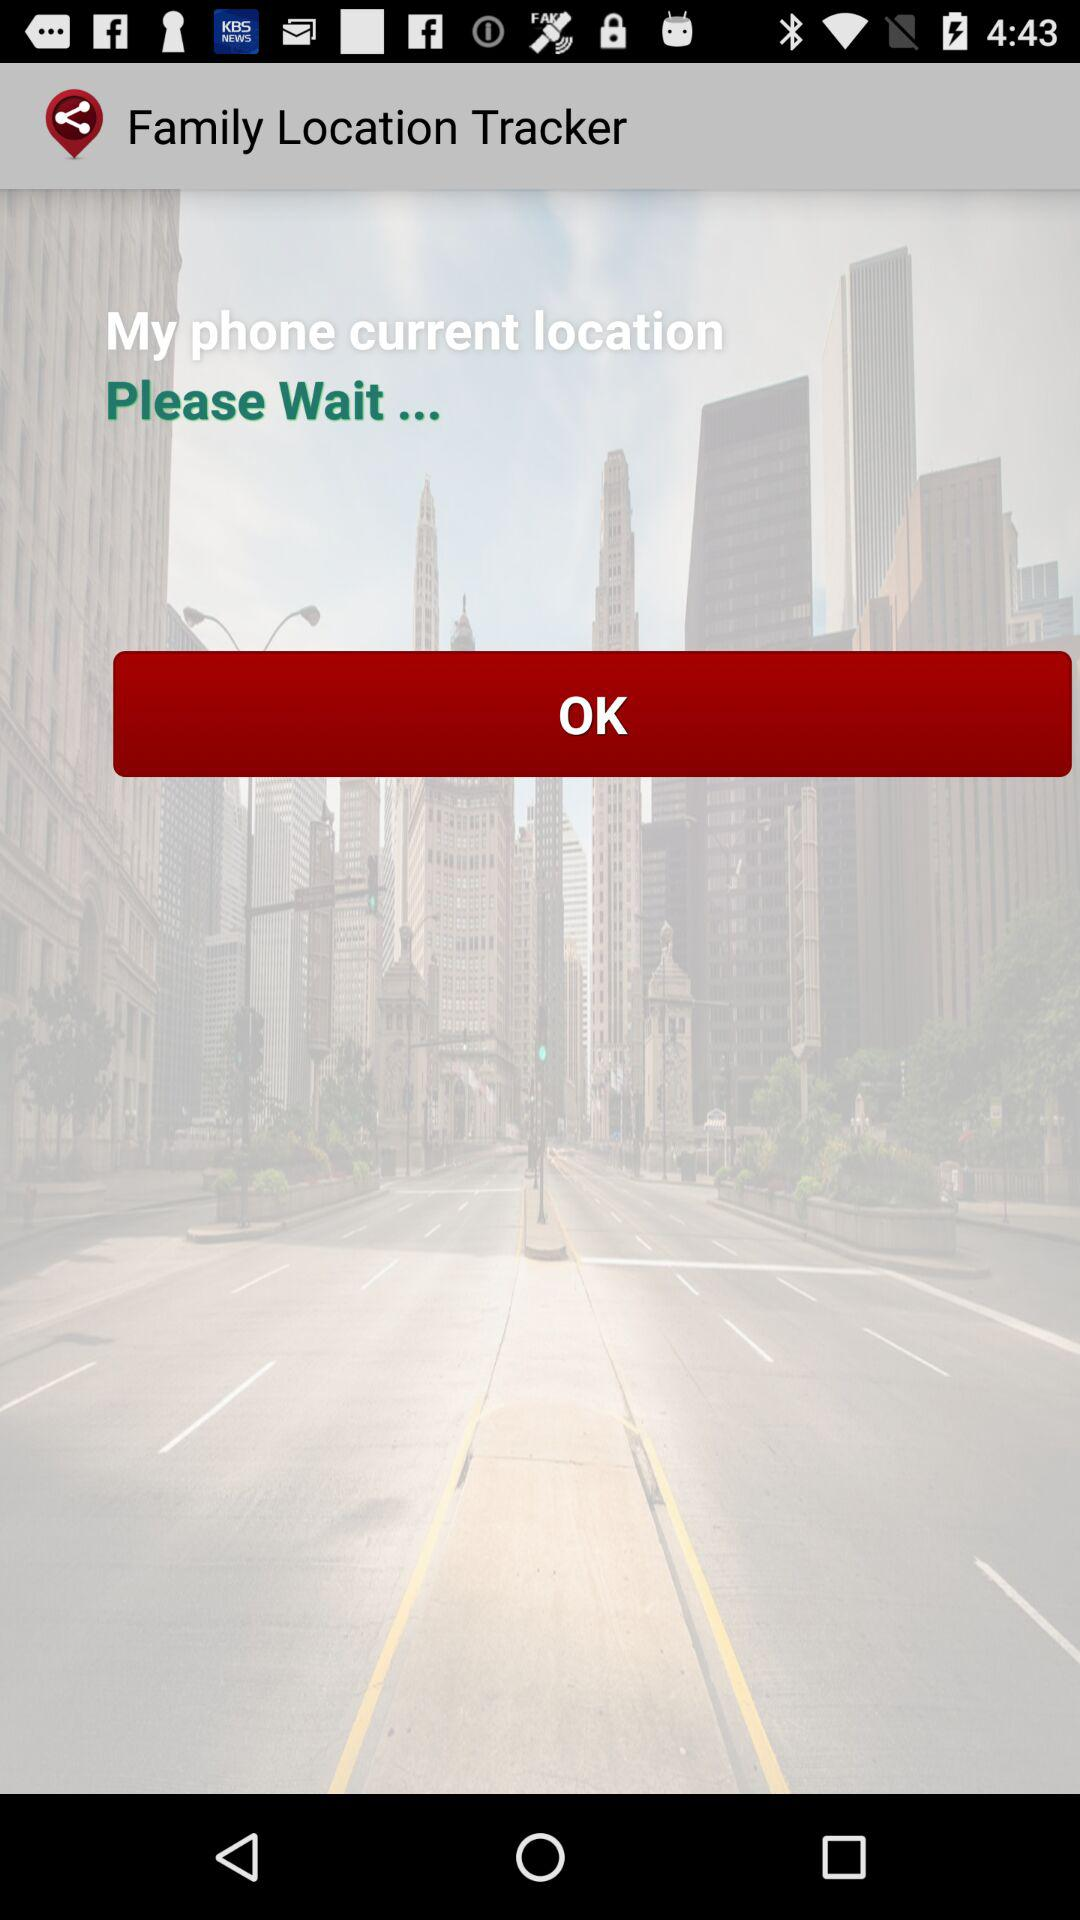What is the name of the application? The name of the application is "Family Location Tracker". 